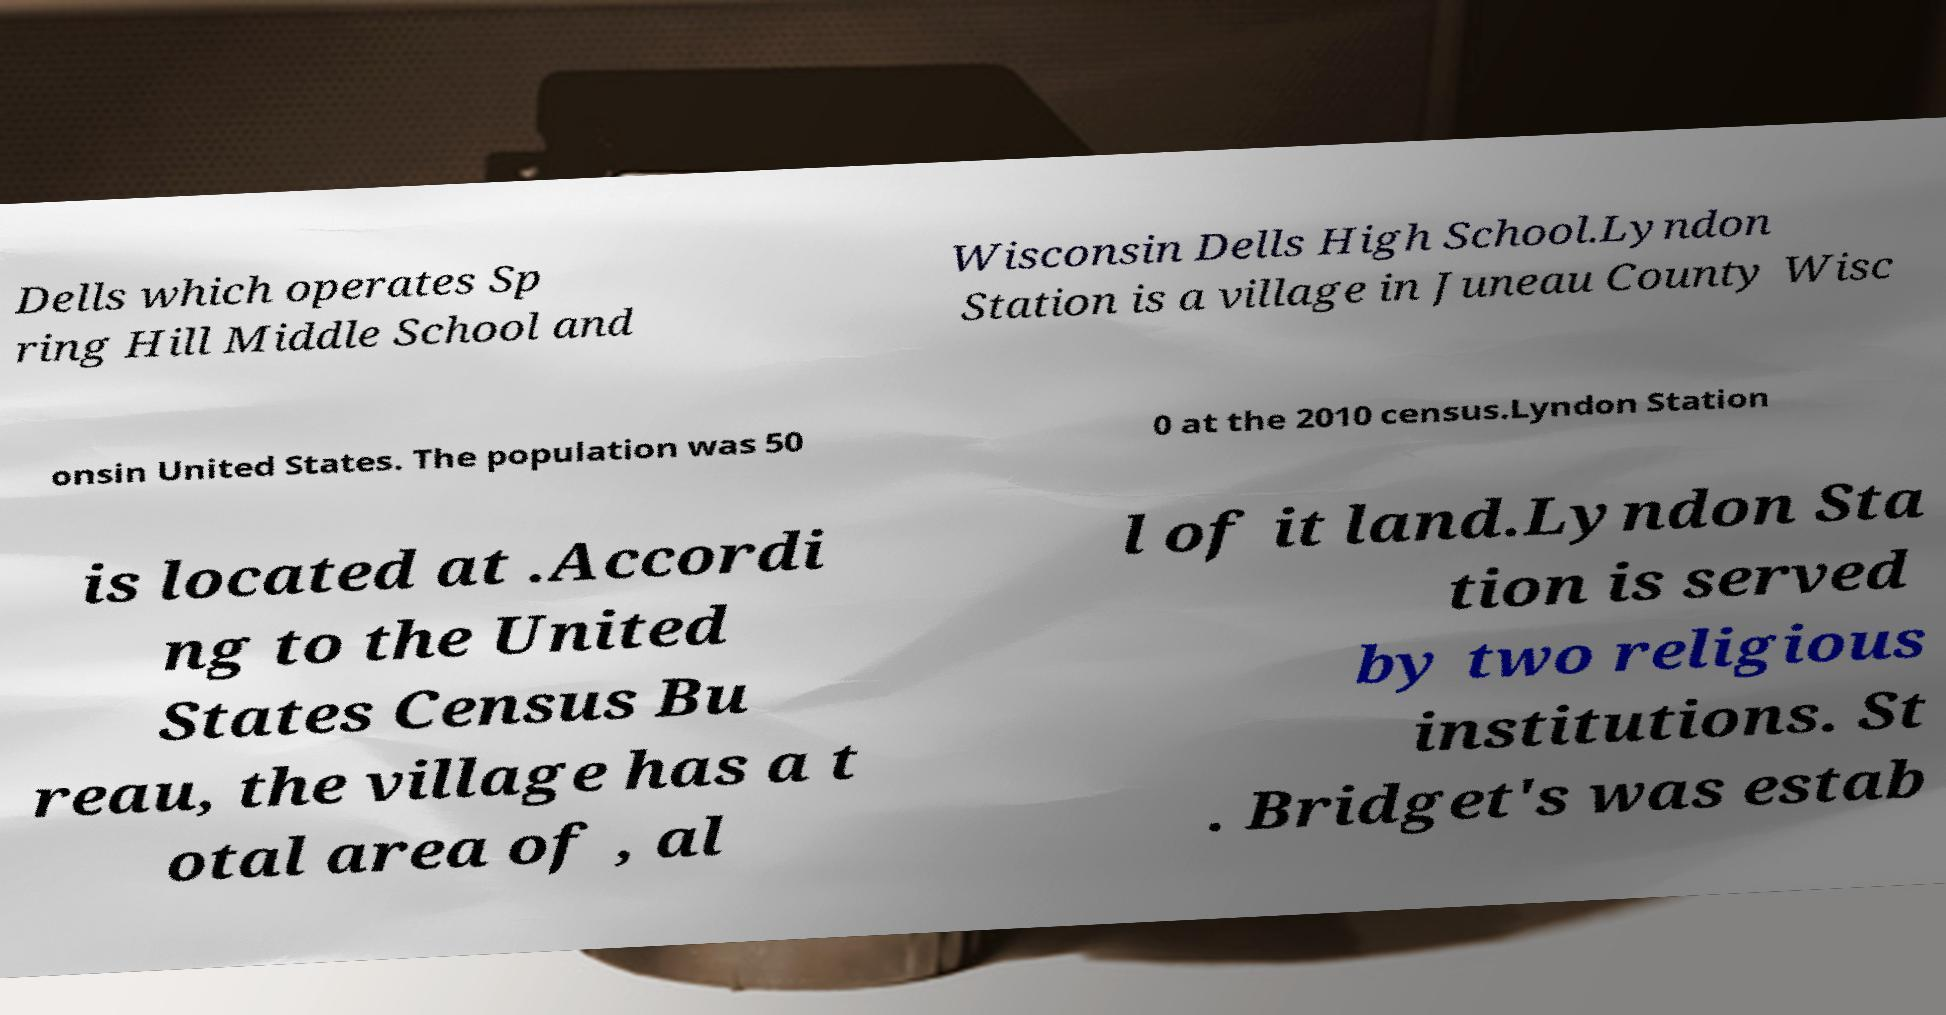What messages or text are displayed in this image? I need them in a readable, typed format. Dells which operates Sp ring Hill Middle School and Wisconsin Dells High School.Lyndon Station is a village in Juneau County Wisc onsin United States. The population was 50 0 at the 2010 census.Lyndon Station is located at .Accordi ng to the United States Census Bu reau, the village has a t otal area of , al l of it land.Lyndon Sta tion is served by two religious institutions. St . Bridget's was estab 